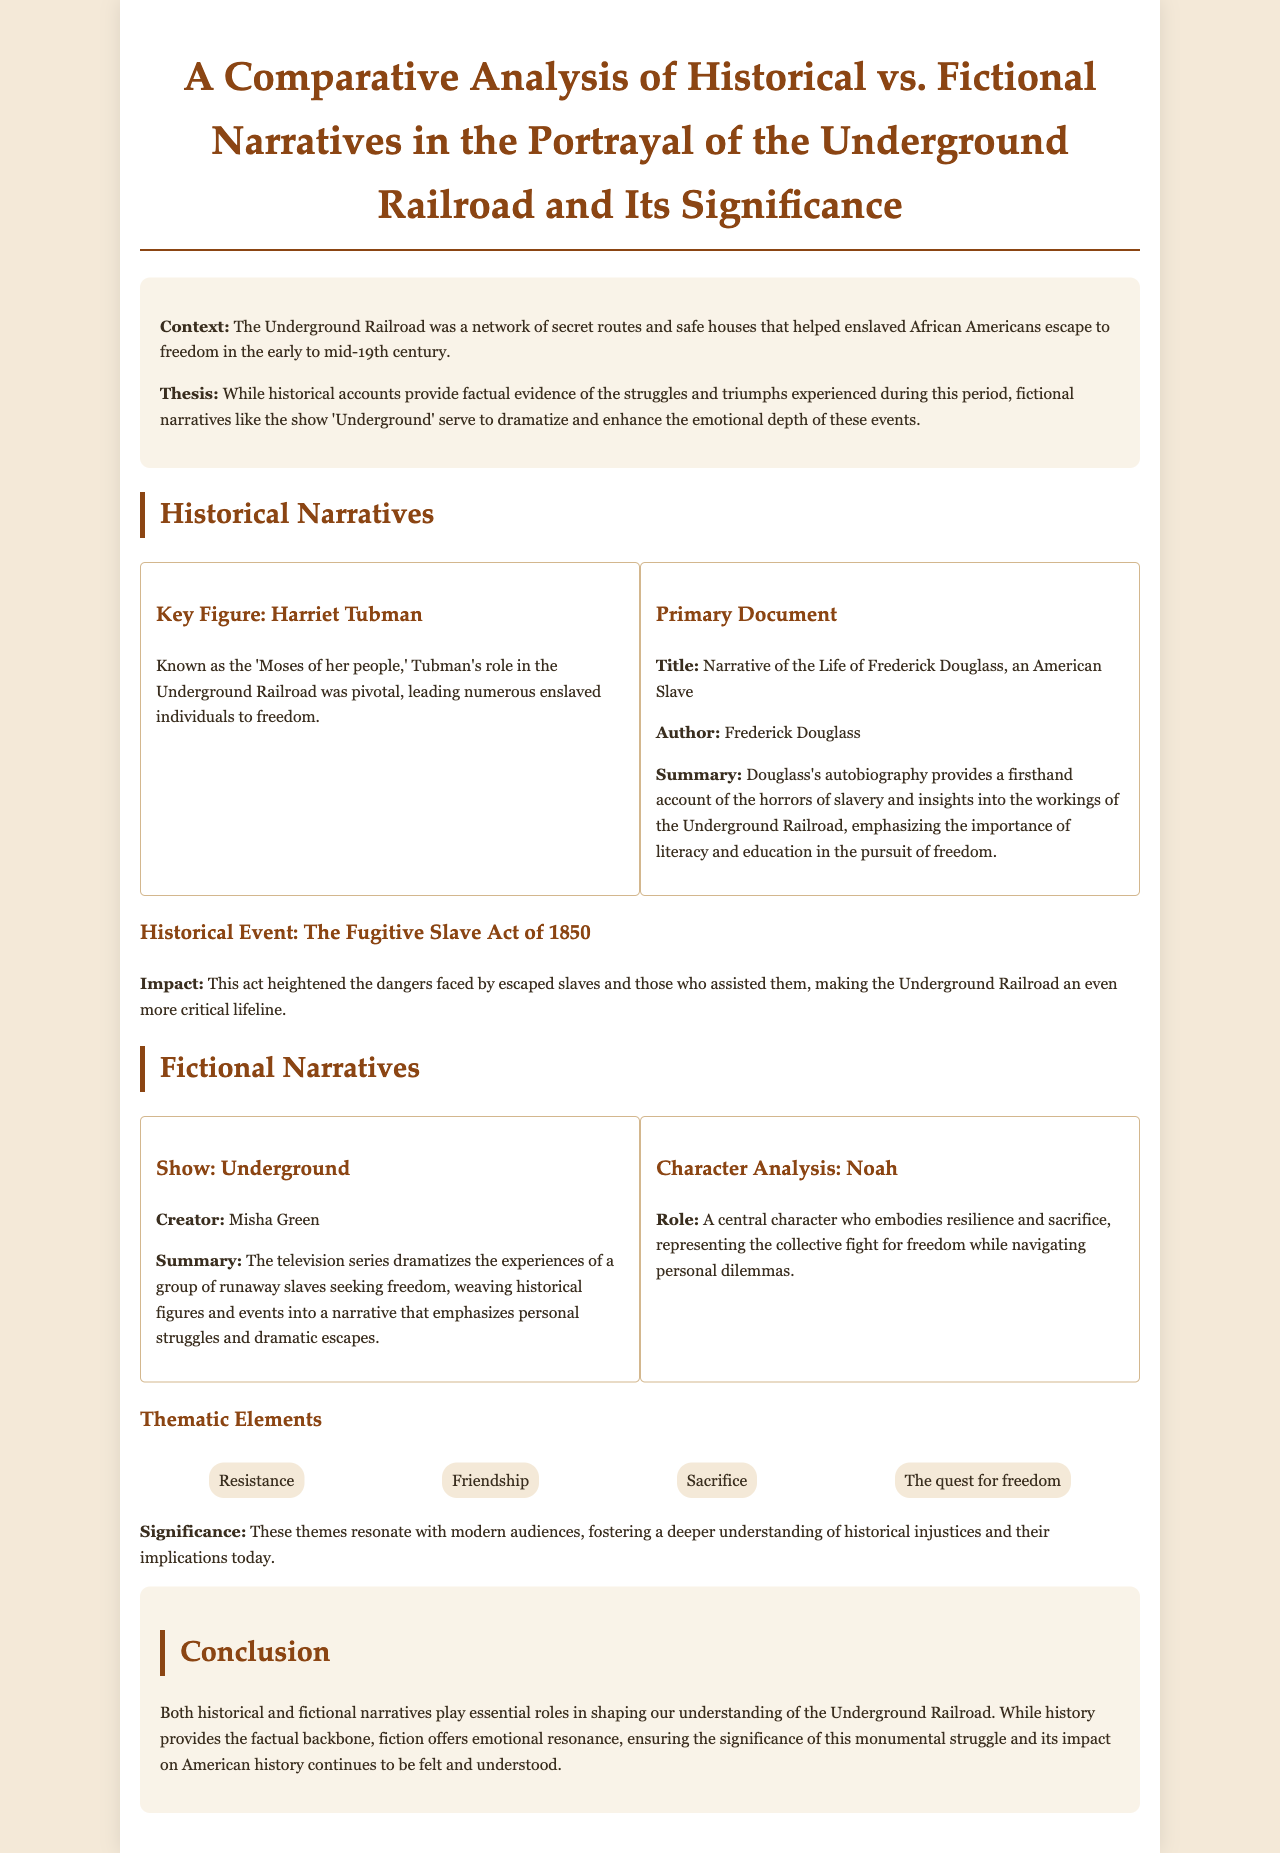What is the title of the document? The title is explicitly mentioned at the beginning of the document and describes the focus of the analysis.
Answer: A Comparative Analysis of Historical vs. Fictional Narratives in the Portrayal of the Underground Railroad and Its Significance Who is known as the 'Moses of her people'? This figure is highlighted in the historical narratives section as pivotal in the Underground Railroad.
Answer: Harriet Tubman What is the title of Frederick Douglass's autobiography? This title is provided under the primary document section summarizing Douglass's contributions and insights.
Answer: Narrative of the Life of Frederick Douglass, an American Slave What historical event heightened the dangers faced by escaped slaves? The document clearly states a specific event that impacted the Underground Railroad's operation.
Answer: The Fugitive Slave Act of 1850 Who created the show 'Underground'? This information is noted in the fictional narratives section, identifying the creator of the dramatization.
Answer: Misha Green What is the role of Noah in the show 'Underground'? The document provides a brief analysis of a character and his significance in the narrative context.
Answer: A central character who embodies resilience and sacrifice Name one thematic element discussed in the document. The thematic elements are listed, signifying core ideas conveyed through the narratives.
Answer: Resistance What emotional aspect does fictional narrative provide according to the document? The document emphasizes how fictional narratives enhance emotional connection to historical events.
Answer: Emotional resonance What two types of narratives are compared in this document? This question addresses the main focus and structure of the document, easily found throughout the content.
Answer: Historical and fictional narratives 